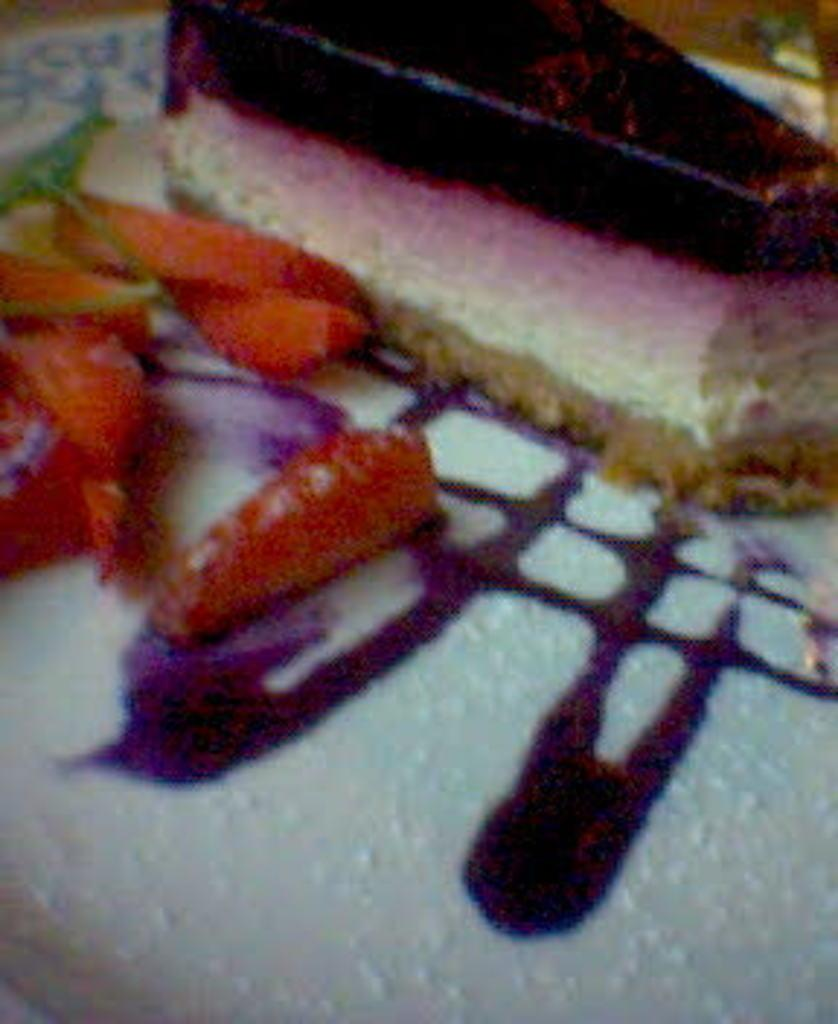What is the main food item in the image? There is a cake piece in the image. What other food items can be seen in the image? There are food items in the image, including a cream on a plate. Can you describe the cream in the image? The cream is present on a plate in the image. What type of adjustment is being made to the mint in the image? There is no mint present in the image, so no adjustment can be made to it. 